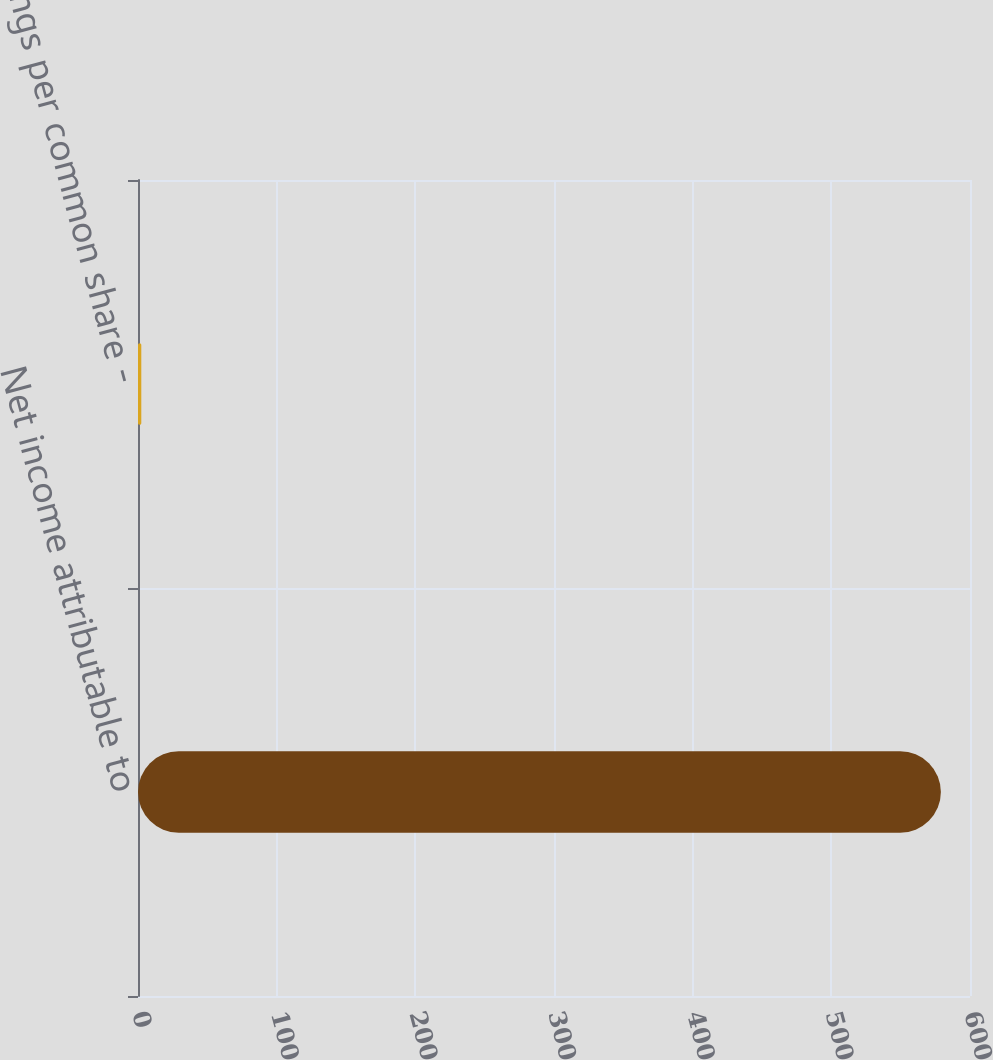<chart> <loc_0><loc_0><loc_500><loc_500><bar_chart><fcel>Net income attributable to<fcel>Earnings per common share -<nl><fcel>579<fcel>2.38<nl></chart> 